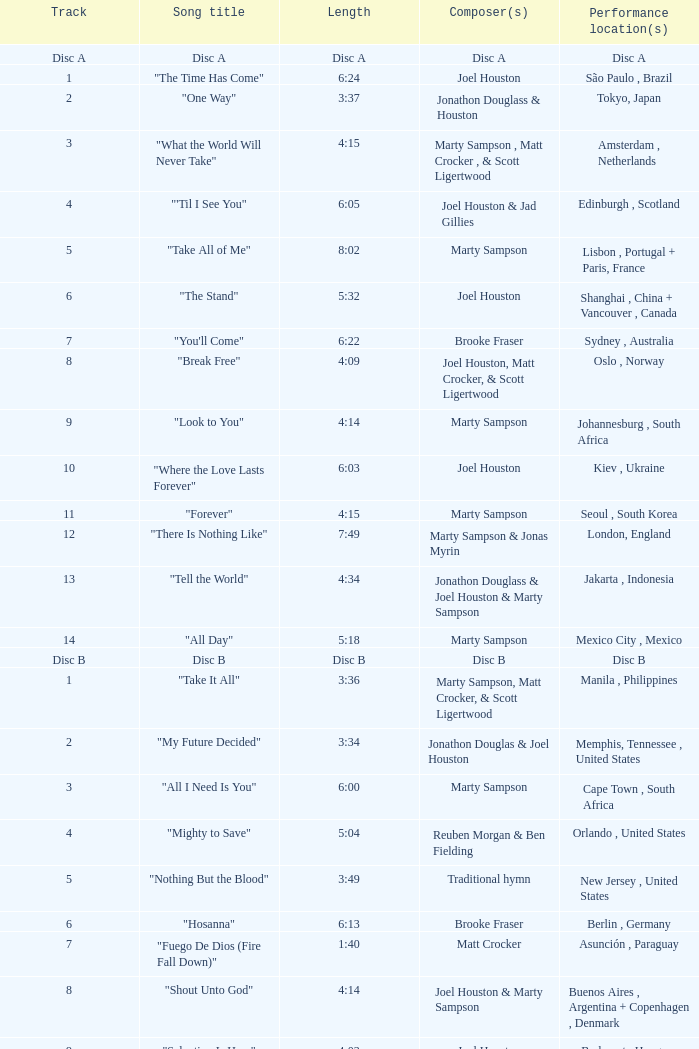What is the lengtho f track 16? 5:55. 